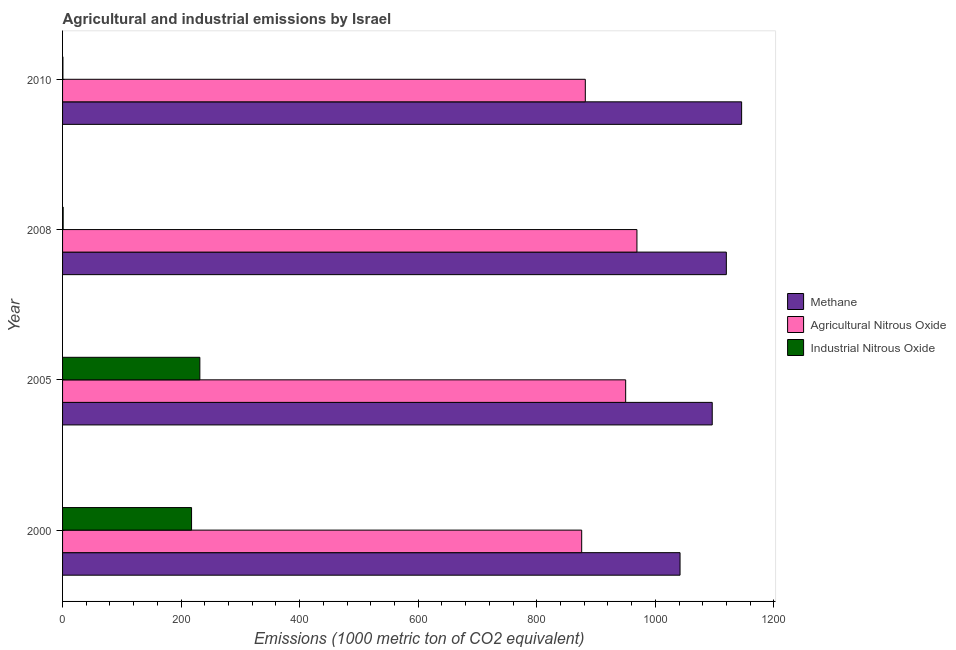How many different coloured bars are there?
Your answer should be compact. 3. How many bars are there on the 4th tick from the top?
Provide a short and direct response. 3. How many bars are there on the 2nd tick from the bottom?
Your answer should be very brief. 3. What is the label of the 2nd group of bars from the top?
Provide a succinct answer. 2008. In how many cases, is the number of bars for a given year not equal to the number of legend labels?
Your answer should be compact. 0. What is the amount of industrial nitrous oxide emissions in 2005?
Offer a terse response. 231.6. Across all years, what is the maximum amount of agricultural nitrous oxide emissions?
Offer a terse response. 968.9. Across all years, what is the minimum amount of industrial nitrous oxide emissions?
Keep it short and to the point. 0.6. In which year was the amount of agricultural nitrous oxide emissions maximum?
Offer a terse response. 2008. What is the total amount of agricultural nitrous oxide emissions in the graph?
Offer a very short reply. 3676.3. What is the difference between the amount of industrial nitrous oxide emissions in 2000 and that in 2010?
Provide a succinct answer. 217. What is the difference between the amount of industrial nitrous oxide emissions in 2000 and the amount of agricultural nitrous oxide emissions in 2008?
Ensure brevity in your answer.  -751.3. What is the average amount of agricultural nitrous oxide emissions per year?
Your answer should be compact. 919.08. In the year 2010, what is the difference between the amount of industrial nitrous oxide emissions and amount of methane emissions?
Offer a very short reply. -1144.9. Is the difference between the amount of methane emissions in 2000 and 2008 greater than the difference between the amount of industrial nitrous oxide emissions in 2000 and 2008?
Offer a very short reply. No. What is the difference between the highest and the second highest amount of agricultural nitrous oxide emissions?
Provide a short and direct response. 19. What is the difference between the highest and the lowest amount of methane emissions?
Make the answer very short. 103.9. Is the sum of the amount of industrial nitrous oxide emissions in 2005 and 2010 greater than the maximum amount of methane emissions across all years?
Provide a short and direct response. No. What does the 2nd bar from the top in 2008 represents?
Keep it short and to the point. Agricultural Nitrous Oxide. What does the 3rd bar from the bottom in 2008 represents?
Your response must be concise. Industrial Nitrous Oxide. Are all the bars in the graph horizontal?
Make the answer very short. Yes. How many years are there in the graph?
Your response must be concise. 4. Does the graph contain grids?
Provide a short and direct response. No. Where does the legend appear in the graph?
Provide a succinct answer. Center right. How are the legend labels stacked?
Provide a succinct answer. Vertical. What is the title of the graph?
Your response must be concise. Agricultural and industrial emissions by Israel. What is the label or title of the X-axis?
Keep it short and to the point. Emissions (1000 metric ton of CO2 equivalent). What is the Emissions (1000 metric ton of CO2 equivalent) of Methane in 2000?
Keep it short and to the point. 1041.6. What is the Emissions (1000 metric ton of CO2 equivalent) in Agricultural Nitrous Oxide in 2000?
Your answer should be compact. 875.7. What is the Emissions (1000 metric ton of CO2 equivalent) in Industrial Nitrous Oxide in 2000?
Make the answer very short. 217.6. What is the Emissions (1000 metric ton of CO2 equivalent) of Methane in 2005?
Your response must be concise. 1095.9. What is the Emissions (1000 metric ton of CO2 equivalent) in Agricultural Nitrous Oxide in 2005?
Ensure brevity in your answer.  949.9. What is the Emissions (1000 metric ton of CO2 equivalent) in Industrial Nitrous Oxide in 2005?
Your answer should be compact. 231.6. What is the Emissions (1000 metric ton of CO2 equivalent) of Methane in 2008?
Give a very brief answer. 1119.7. What is the Emissions (1000 metric ton of CO2 equivalent) in Agricultural Nitrous Oxide in 2008?
Make the answer very short. 968.9. What is the Emissions (1000 metric ton of CO2 equivalent) of Industrial Nitrous Oxide in 2008?
Keep it short and to the point. 1. What is the Emissions (1000 metric ton of CO2 equivalent) of Methane in 2010?
Keep it short and to the point. 1145.5. What is the Emissions (1000 metric ton of CO2 equivalent) of Agricultural Nitrous Oxide in 2010?
Your response must be concise. 881.8. Across all years, what is the maximum Emissions (1000 metric ton of CO2 equivalent) in Methane?
Your response must be concise. 1145.5. Across all years, what is the maximum Emissions (1000 metric ton of CO2 equivalent) of Agricultural Nitrous Oxide?
Your answer should be compact. 968.9. Across all years, what is the maximum Emissions (1000 metric ton of CO2 equivalent) in Industrial Nitrous Oxide?
Your answer should be very brief. 231.6. Across all years, what is the minimum Emissions (1000 metric ton of CO2 equivalent) of Methane?
Ensure brevity in your answer.  1041.6. Across all years, what is the minimum Emissions (1000 metric ton of CO2 equivalent) of Agricultural Nitrous Oxide?
Keep it short and to the point. 875.7. What is the total Emissions (1000 metric ton of CO2 equivalent) in Methane in the graph?
Make the answer very short. 4402.7. What is the total Emissions (1000 metric ton of CO2 equivalent) in Agricultural Nitrous Oxide in the graph?
Ensure brevity in your answer.  3676.3. What is the total Emissions (1000 metric ton of CO2 equivalent) of Industrial Nitrous Oxide in the graph?
Give a very brief answer. 450.8. What is the difference between the Emissions (1000 metric ton of CO2 equivalent) of Methane in 2000 and that in 2005?
Your answer should be compact. -54.3. What is the difference between the Emissions (1000 metric ton of CO2 equivalent) of Agricultural Nitrous Oxide in 2000 and that in 2005?
Offer a terse response. -74.2. What is the difference between the Emissions (1000 metric ton of CO2 equivalent) of Methane in 2000 and that in 2008?
Offer a very short reply. -78.1. What is the difference between the Emissions (1000 metric ton of CO2 equivalent) of Agricultural Nitrous Oxide in 2000 and that in 2008?
Offer a terse response. -93.2. What is the difference between the Emissions (1000 metric ton of CO2 equivalent) in Industrial Nitrous Oxide in 2000 and that in 2008?
Offer a terse response. 216.6. What is the difference between the Emissions (1000 metric ton of CO2 equivalent) in Methane in 2000 and that in 2010?
Give a very brief answer. -103.9. What is the difference between the Emissions (1000 metric ton of CO2 equivalent) of Agricultural Nitrous Oxide in 2000 and that in 2010?
Provide a succinct answer. -6.1. What is the difference between the Emissions (1000 metric ton of CO2 equivalent) of Industrial Nitrous Oxide in 2000 and that in 2010?
Provide a short and direct response. 217. What is the difference between the Emissions (1000 metric ton of CO2 equivalent) of Methane in 2005 and that in 2008?
Your response must be concise. -23.8. What is the difference between the Emissions (1000 metric ton of CO2 equivalent) of Industrial Nitrous Oxide in 2005 and that in 2008?
Give a very brief answer. 230.6. What is the difference between the Emissions (1000 metric ton of CO2 equivalent) of Methane in 2005 and that in 2010?
Offer a very short reply. -49.6. What is the difference between the Emissions (1000 metric ton of CO2 equivalent) in Agricultural Nitrous Oxide in 2005 and that in 2010?
Your answer should be very brief. 68.1. What is the difference between the Emissions (1000 metric ton of CO2 equivalent) of Industrial Nitrous Oxide in 2005 and that in 2010?
Provide a short and direct response. 231. What is the difference between the Emissions (1000 metric ton of CO2 equivalent) of Methane in 2008 and that in 2010?
Offer a very short reply. -25.8. What is the difference between the Emissions (1000 metric ton of CO2 equivalent) of Agricultural Nitrous Oxide in 2008 and that in 2010?
Keep it short and to the point. 87.1. What is the difference between the Emissions (1000 metric ton of CO2 equivalent) in Methane in 2000 and the Emissions (1000 metric ton of CO2 equivalent) in Agricultural Nitrous Oxide in 2005?
Offer a very short reply. 91.7. What is the difference between the Emissions (1000 metric ton of CO2 equivalent) in Methane in 2000 and the Emissions (1000 metric ton of CO2 equivalent) in Industrial Nitrous Oxide in 2005?
Give a very brief answer. 810. What is the difference between the Emissions (1000 metric ton of CO2 equivalent) of Agricultural Nitrous Oxide in 2000 and the Emissions (1000 metric ton of CO2 equivalent) of Industrial Nitrous Oxide in 2005?
Offer a terse response. 644.1. What is the difference between the Emissions (1000 metric ton of CO2 equivalent) in Methane in 2000 and the Emissions (1000 metric ton of CO2 equivalent) in Agricultural Nitrous Oxide in 2008?
Provide a short and direct response. 72.7. What is the difference between the Emissions (1000 metric ton of CO2 equivalent) in Methane in 2000 and the Emissions (1000 metric ton of CO2 equivalent) in Industrial Nitrous Oxide in 2008?
Your answer should be very brief. 1040.6. What is the difference between the Emissions (1000 metric ton of CO2 equivalent) of Agricultural Nitrous Oxide in 2000 and the Emissions (1000 metric ton of CO2 equivalent) of Industrial Nitrous Oxide in 2008?
Make the answer very short. 874.7. What is the difference between the Emissions (1000 metric ton of CO2 equivalent) of Methane in 2000 and the Emissions (1000 metric ton of CO2 equivalent) of Agricultural Nitrous Oxide in 2010?
Give a very brief answer. 159.8. What is the difference between the Emissions (1000 metric ton of CO2 equivalent) in Methane in 2000 and the Emissions (1000 metric ton of CO2 equivalent) in Industrial Nitrous Oxide in 2010?
Offer a terse response. 1041. What is the difference between the Emissions (1000 metric ton of CO2 equivalent) in Agricultural Nitrous Oxide in 2000 and the Emissions (1000 metric ton of CO2 equivalent) in Industrial Nitrous Oxide in 2010?
Give a very brief answer. 875.1. What is the difference between the Emissions (1000 metric ton of CO2 equivalent) of Methane in 2005 and the Emissions (1000 metric ton of CO2 equivalent) of Agricultural Nitrous Oxide in 2008?
Your answer should be compact. 127. What is the difference between the Emissions (1000 metric ton of CO2 equivalent) in Methane in 2005 and the Emissions (1000 metric ton of CO2 equivalent) in Industrial Nitrous Oxide in 2008?
Your answer should be compact. 1094.9. What is the difference between the Emissions (1000 metric ton of CO2 equivalent) in Agricultural Nitrous Oxide in 2005 and the Emissions (1000 metric ton of CO2 equivalent) in Industrial Nitrous Oxide in 2008?
Offer a very short reply. 948.9. What is the difference between the Emissions (1000 metric ton of CO2 equivalent) of Methane in 2005 and the Emissions (1000 metric ton of CO2 equivalent) of Agricultural Nitrous Oxide in 2010?
Provide a short and direct response. 214.1. What is the difference between the Emissions (1000 metric ton of CO2 equivalent) in Methane in 2005 and the Emissions (1000 metric ton of CO2 equivalent) in Industrial Nitrous Oxide in 2010?
Your answer should be compact. 1095.3. What is the difference between the Emissions (1000 metric ton of CO2 equivalent) in Agricultural Nitrous Oxide in 2005 and the Emissions (1000 metric ton of CO2 equivalent) in Industrial Nitrous Oxide in 2010?
Keep it short and to the point. 949.3. What is the difference between the Emissions (1000 metric ton of CO2 equivalent) in Methane in 2008 and the Emissions (1000 metric ton of CO2 equivalent) in Agricultural Nitrous Oxide in 2010?
Offer a very short reply. 237.9. What is the difference between the Emissions (1000 metric ton of CO2 equivalent) of Methane in 2008 and the Emissions (1000 metric ton of CO2 equivalent) of Industrial Nitrous Oxide in 2010?
Your answer should be compact. 1119.1. What is the difference between the Emissions (1000 metric ton of CO2 equivalent) of Agricultural Nitrous Oxide in 2008 and the Emissions (1000 metric ton of CO2 equivalent) of Industrial Nitrous Oxide in 2010?
Your response must be concise. 968.3. What is the average Emissions (1000 metric ton of CO2 equivalent) of Methane per year?
Your response must be concise. 1100.67. What is the average Emissions (1000 metric ton of CO2 equivalent) in Agricultural Nitrous Oxide per year?
Offer a very short reply. 919.08. What is the average Emissions (1000 metric ton of CO2 equivalent) of Industrial Nitrous Oxide per year?
Offer a very short reply. 112.7. In the year 2000, what is the difference between the Emissions (1000 metric ton of CO2 equivalent) of Methane and Emissions (1000 metric ton of CO2 equivalent) of Agricultural Nitrous Oxide?
Make the answer very short. 165.9. In the year 2000, what is the difference between the Emissions (1000 metric ton of CO2 equivalent) in Methane and Emissions (1000 metric ton of CO2 equivalent) in Industrial Nitrous Oxide?
Provide a succinct answer. 824. In the year 2000, what is the difference between the Emissions (1000 metric ton of CO2 equivalent) of Agricultural Nitrous Oxide and Emissions (1000 metric ton of CO2 equivalent) of Industrial Nitrous Oxide?
Keep it short and to the point. 658.1. In the year 2005, what is the difference between the Emissions (1000 metric ton of CO2 equivalent) in Methane and Emissions (1000 metric ton of CO2 equivalent) in Agricultural Nitrous Oxide?
Provide a short and direct response. 146. In the year 2005, what is the difference between the Emissions (1000 metric ton of CO2 equivalent) in Methane and Emissions (1000 metric ton of CO2 equivalent) in Industrial Nitrous Oxide?
Offer a terse response. 864.3. In the year 2005, what is the difference between the Emissions (1000 metric ton of CO2 equivalent) of Agricultural Nitrous Oxide and Emissions (1000 metric ton of CO2 equivalent) of Industrial Nitrous Oxide?
Your answer should be very brief. 718.3. In the year 2008, what is the difference between the Emissions (1000 metric ton of CO2 equivalent) of Methane and Emissions (1000 metric ton of CO2 equivalent) of Agricultural Nitrous Oxide?
Your response must be concise. 150.8. In the year 2008, what is the difference between the Emissions (1000 metric ton of CO2 equivalent) of Methane and Emissions (1000 metric ton of CO2 equivalent) of Industrial Nitrous Oxide?
Your answer should be very brief. 1118.7. In the year 2008, what is the difference between the Emissions (1000 metric ton of CO2 equivalent) of Agricultural Nitrous Oxide and Emissions (1000 metric ton of CO2 equivalent) of Industrial Nitrous Oxide?
Keep it short and to the point. 967.9. In the year 2010, what is the difference between the Emissions (1000 metric ton of CO2 equivalent) in Methane and Emissions (1000 metric ton of CO2 equivalent) in Agricultural Nitrous Oxide?
Offer a very short reply. 263.7. In the year 2010, what is the difference between the Emissions (1000 metric ton of CO2 equivalent) in Methane and Emissions (1000 metric ton of CO2 equivalent) in Industrial Nitrous Oxide?
Make the answer very short. 1144.9. In the year 2010, what is the difference between the Emissions (1000 metric ton of CO2 equivalent) of Agricultural Nitrous Oxide and Emissions (1000 metric ton of CO2 equivalent) of Industrial Nitrous Oxide?
Offer a terse response. 881.2. What is the ratio of the Emissions (1000 metric ton of CO2 equivalent) of Methane in 2000 to that in 2005?
Your response must be concise. 0.95. What is the ratio of the Emissions (1000 metric ton of CO2 equivalent) in Agricultural Nitrous Oxide in 2000 to that in 2005?
Ensure brevity in your answer.  0.92. What is the ratio of the Emissions (1000 metric ton of CO2 equivalent) of Industrial Nitrous Oxide in 2000 to that in 2005?
Keep it short and to the point. 0.94. What is the ratio of the Emissions (1000 metric ton of CO2 equivalent) in Methane in 2000 to that in 2008?
Provide a succinct answer. 0.93. What is the ratio of the Emissions (1000 metric ton of CO2 equivalent) of Agricultural Nitrous Oxide in 2000 to that in 2008?
Give a very brief answer. 0.9. What is the ratio of the Emissions (1000 metric ton of CO2 equivalent) in Industrial Nitrous Oxide in 2000 to that in 2008?
Your answer should be very brief. 217.6. What is the ratio of the Emissions (1000 metric ton of CO2 equivalent) in Methane in 2000 to that in 2010?
Provide a succinct answer. 0.91. What is the ratio of the Emissions (1000 metric ton of CO2 equivalent) of Agricultural Nitrous Oxide in 2000 to that in 2010?
Provide a succinct answer. 0.99. What is the ratio of the Emissions (1000 metric ton of CO2 equivalent) of Industrial Nitrous Oxide in 2000 to that in 2010?
Offer a terse response. 362.67. What is the ratio of the Emissions (1000 metric ton of CO2 equivalent) in Methane in 2005 to that in 2008?
Ensure brevity in your answer.  0.98. What is the ratio of the Emissions (1000 metric ton of CO2 equivalent) of Agricultural Nitrous Oxide in 2005 to that in 2008?
Provide a short and direct response. 0.98. What is the ratio of the Emissions (1000 metric ton of CO2 equivalent) of Industrial Nitrous Oxide in 2005 to that in 2008?
Offer a very short reply. 231.6. What is the ratio of the Emissions (1000 metric ton of CO2 equivalent) in Methane in 2005 to that in 2010?
Keep it short and to the point. 0.96. What is the ratio of the Emissions (1000 metric ton of CO2 equivalent) of Agricultural Nitrous Oxide in 2005 to that in 2010?
Provide a succinct answer. 1.08. What is the ratio of the Emissions (1000 metric ton of CO2 equivalent) of Industrial Nitrous Oxide in 2005 to that in 2010?
Give a very brief answer. 386. What is the ratio of the Emissions (1000 metric ton of CO2 equivalent) of Methane in 2008 to that in 2010?
Your answer should be very brief. 0.98. What is the ratio of the Emissions (1000 metric ton of CO2 equivalent) of Agricultural Nitrous Oxide in 2008 to that in 2010?
Your answer should be very brief. 1.1. What is the ratio of the Emissions (1000 metric ton of CO2 equivalent) in Industrial Nitrous Oxide in 2008 to that in 2010?
Provide a short and direct response. 1.67. What is the difference between the highest and the second highest Emissions (1000 metric ton of CO2 equivalent) of Methane?
Make the answer very short. 25.8. What is the difference between the highest and the second highest Emissions (1000 metric ton of CO2 equivalent) of Agricultural Nitrous Oxide?
Offer a terse response. 19. What is the difference between the highest and the lowest Emissions (1000 metric ton of CO2 equivalent) in Methane?
Give a very brief answer. 103.9. What is the difference between the highest and the lowest Emissions (1000 metric ton of CO2 equivalent) in Agricultural Nitrous Oxide?
Ensure brevity in your answer.  93.2. What is the difference between the highest and the lowest Emissions (1000 metric ton of CO2 equivalent) in Industrial Nitrous Oxide?
Make the answer very short. 231. 